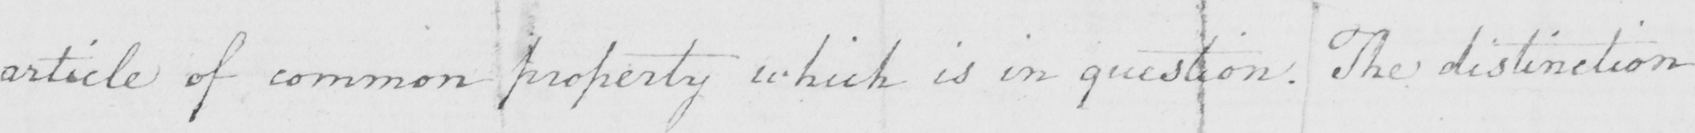Please transcribe the handwritten text in this image. article of common property which is in question . The distinction 